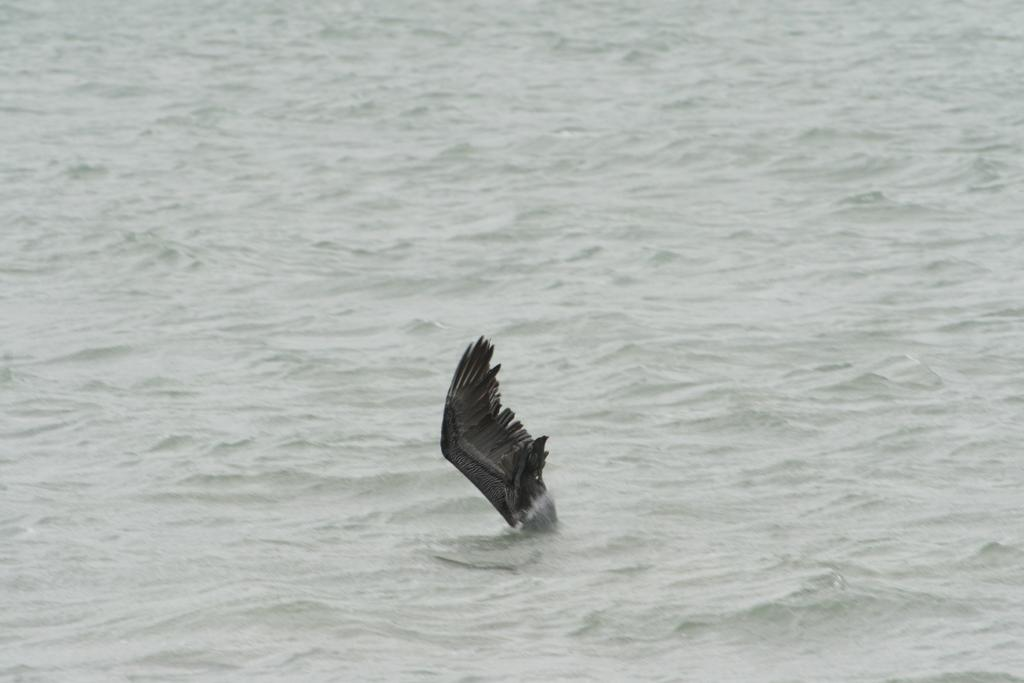What type of animal is in the image? There is a bird in the image. What is the bird doing in the image? The bird is touching the water. What body of water is visible in the image? There is a river or ocean visible at the top of the image. What type of can is being held by the stranger in the image? There is no stranger or can present in the image. What is the secretary doing in the image? There is no secretary present in the image. 